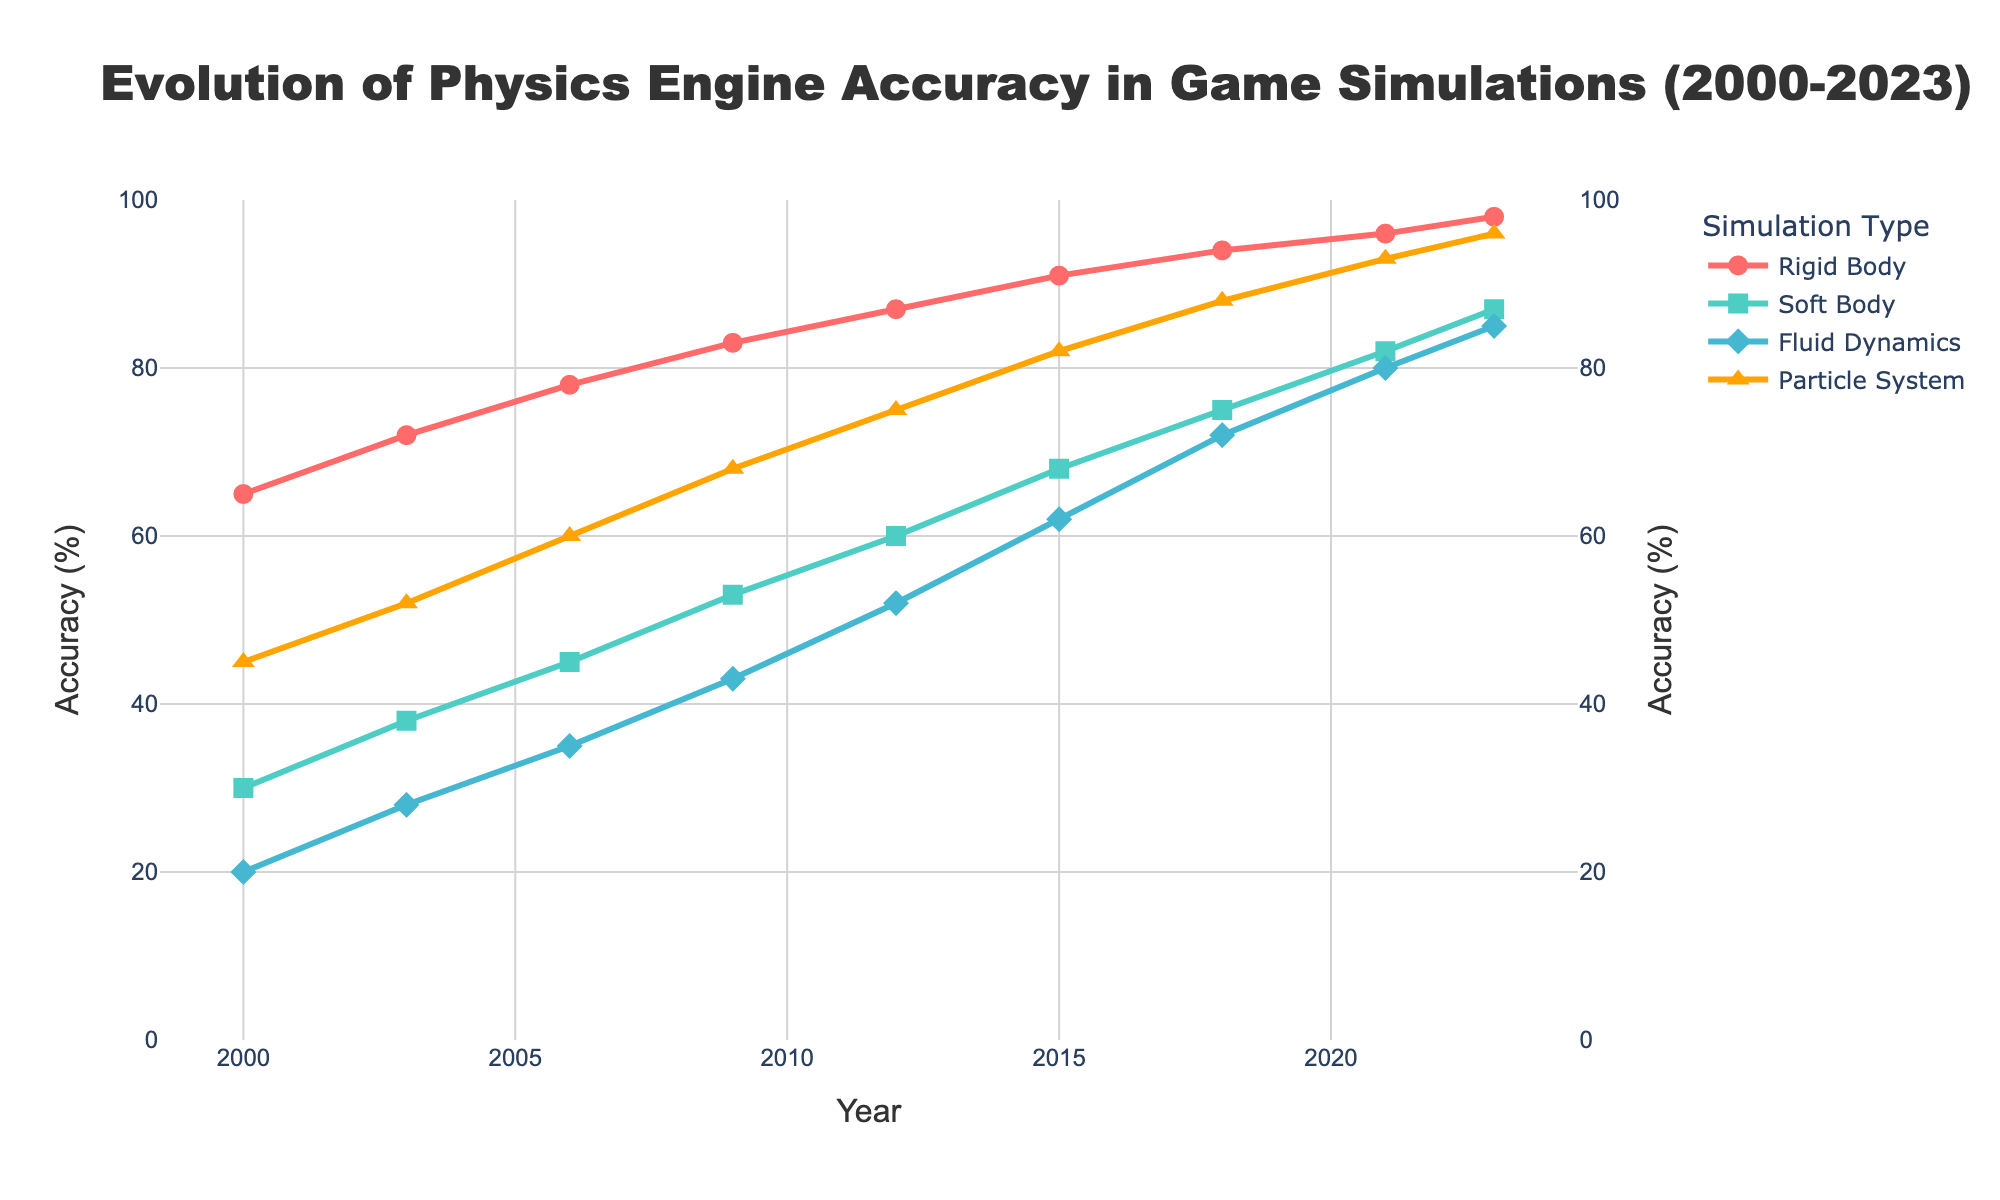What is the overall trend of Rigid Body Accuracy from 2000 to 2023? The accuracy of Rigid Body systems increases consistently over the years from 65% in 2000 to 98% in 2023, indicating significant improvements and regular enhancements in their performance.
Answer: Increasing Which simulation type shows the highest accuracy in 2023? In 2023, the Particle System Accuracy is represented with a triangle-up symbol and has the highest value among all, reaching 96%.
Answer: Particle System How does the improvement in Fluid Dynamics Accuracy between 2012 and 2023 compare to the improvement in Soft Body Accuracy over the same period? To compare, we note that Fluid Dynamics Accuracy improves from 52% to 85% (an increase of 33%), while Soft Body Accuracy improves from 60% to 87% (an increase of 27%). Thus, Fluid Dynamics Accuracy has a higher improvement.
Answer: Fluid Dynamics improved more What is the accuracy difference between Rigid Body and Particle System in 2006? Rigid Body Accuracy in 2006 is 78%, and Particle System Accuracy is 60%. The difference is 78 - 60 = 18%.
Answer: 18% Which simulation type has the least improvement from 2000 to 2023? From 2000 to 2023, Soft Body Accuracy improved from 30% to 87% (an improvement of 57%), which is less than Rigid Body (98 - 65 = 33%), Fluid Dynamics (85 - 20 = 65%), and Particle System (96 - 45 = 51%). Hence, Soft Body has the least improvement.
Answer: Soft Body How did the accuracy of Fluid Dynamics and Particle System simulations change between 2003 and 2009? From 2003 to 2009, Fluid Dynamics Accuracy increased from 28% to 43%, and Particle System Accuracy increased from 52% to 68%. Fluid Dynamics improved by 15%, and Particle System improved by 16%.
Answer: Both improved What is the average accuracy of Rigid Body simulations in 2000 and 2023? The accuracy of Rigid Body simulations is 65% in 2000 and 98% in 2023. The average is (65 + 98) / 2 = 81.5%.
Answer: 81.5% Which year shows the greatest increase in Soft Body Accuracy? To find the greatest increase, we compare biennial increments: 2000 to 2003 (8%), 2003 to 2006 (7%), 2006 to 2009 (8%), 2009 to 2012 (7%), 2012 to 2015 (8%), 2015 to 2018 (7%), 2018 to 2021 (7%), and 2021 to 2023 (5%). Thus, the year with the greatest increase was 2009.
Answer: 2009 In which year did Rigid Body Accuracy surpass 90%? Rigid Body Accuracy surpassed 90% in 2015 with an accuracy of 91%.
Answer: 2015 